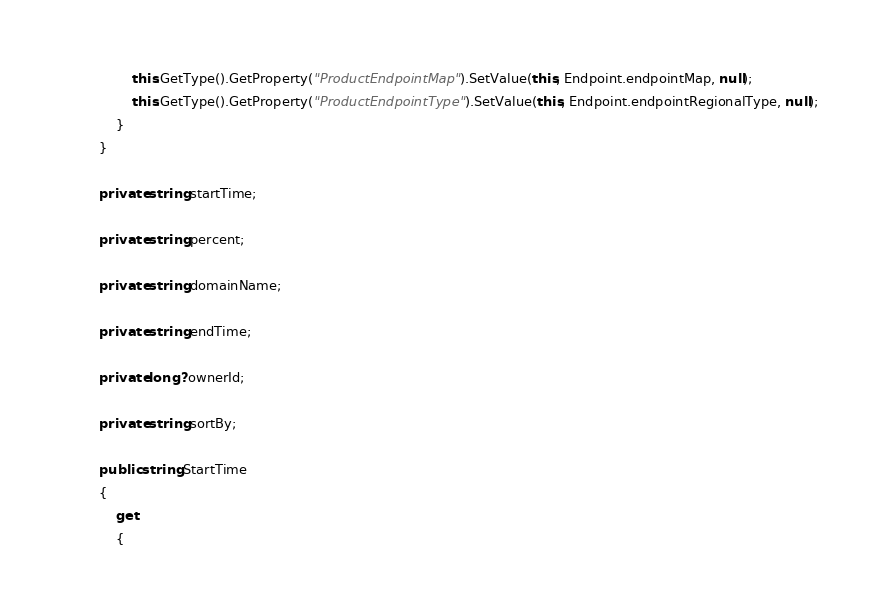Convert code to text. <code><loc_0><loc_0><loc_500><loc_500><_C#_>                this.GetType().GetProperty("ProductEndpointMap").SetValue(this, Endpoint.endpointMap, null);
                this.GetType().GetProperty("ProductEndpointType").SetValue(this, Endpoint.endpointRegionalType, null);
            }
        }

		private string startTime;

		private string percent;

		private string domainName;

		private string endTime;

		private long? ownerId;

		private string sortBy;

		public string StartTime
		{
			get
			{</code> 